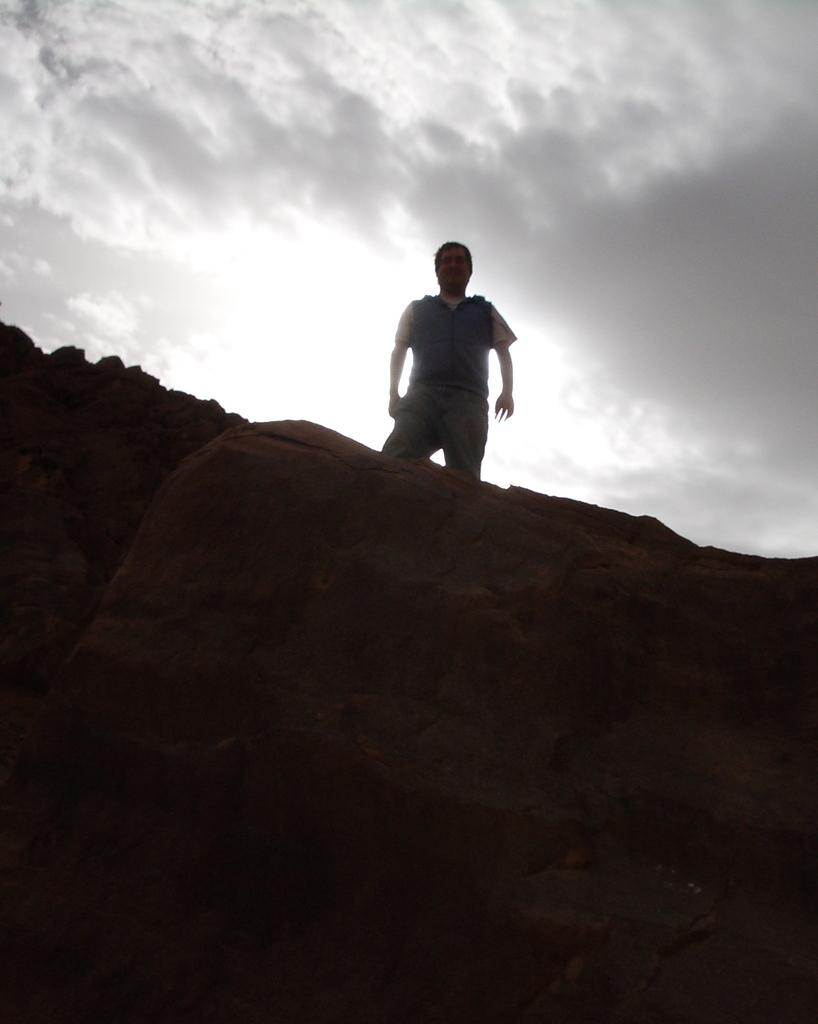What can be seen at the top of the image? The sky is visible towards the top of the image. What is located at the bottom of the image? There are rocks towards the bottom of the image. Can you describe the man in the image? There is a man standing on one of the rocks. What type of print can be seen on the man's ear in the image? There is no print visible on the man's ear in the image, as the man's ear is not mentioned in the provided facts. --- 